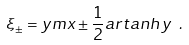<formula> <loc_0><loc_0><loc_500><loc_500>\xi _ { \pm } = y m x \pm \frac { 1 } { 2 } a r t a n h \, y \ .</formula> 